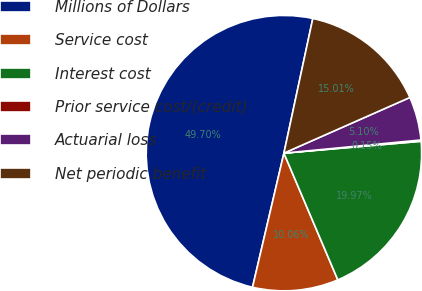Convert chart. <chart><loc_0><loc_0><loc_500><loc_500><pie_chart><fcel>Millions of Dollars<fcel>Service cost<fcel>Interest cost<fcel>Prior service cost/(credit)<fcel>Actuarial loss<fcel>Net periodic benefit<nl><fcel>49.7%<fcel>10.06%<fcel>19.97%<fcel>0.15%<fcel>5.1%<fcel>15.01%<nl></chart> 